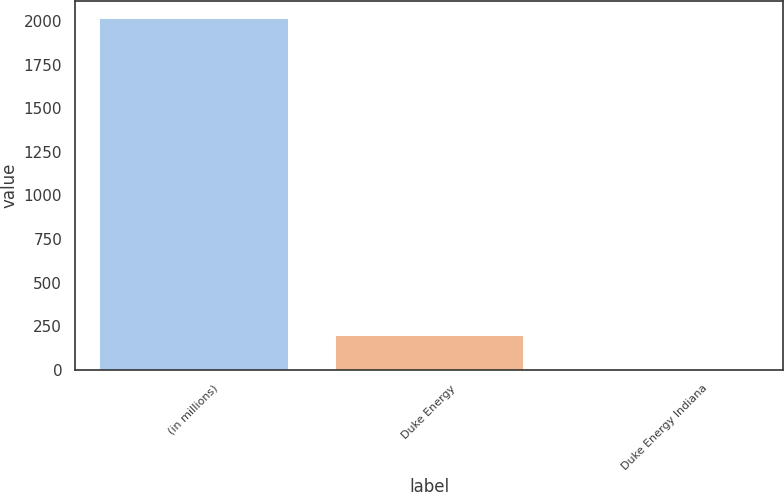Convert chart to OTSL. <chart><loc_0><loc_0><loc_500><loc_500><bar_chart><fcel>(in millions)<fcel>Duke Energy<fcel>Duke Energy Indiana<nl><fcel>2016<fcel>202.5<fcel>1<nl></chart> 